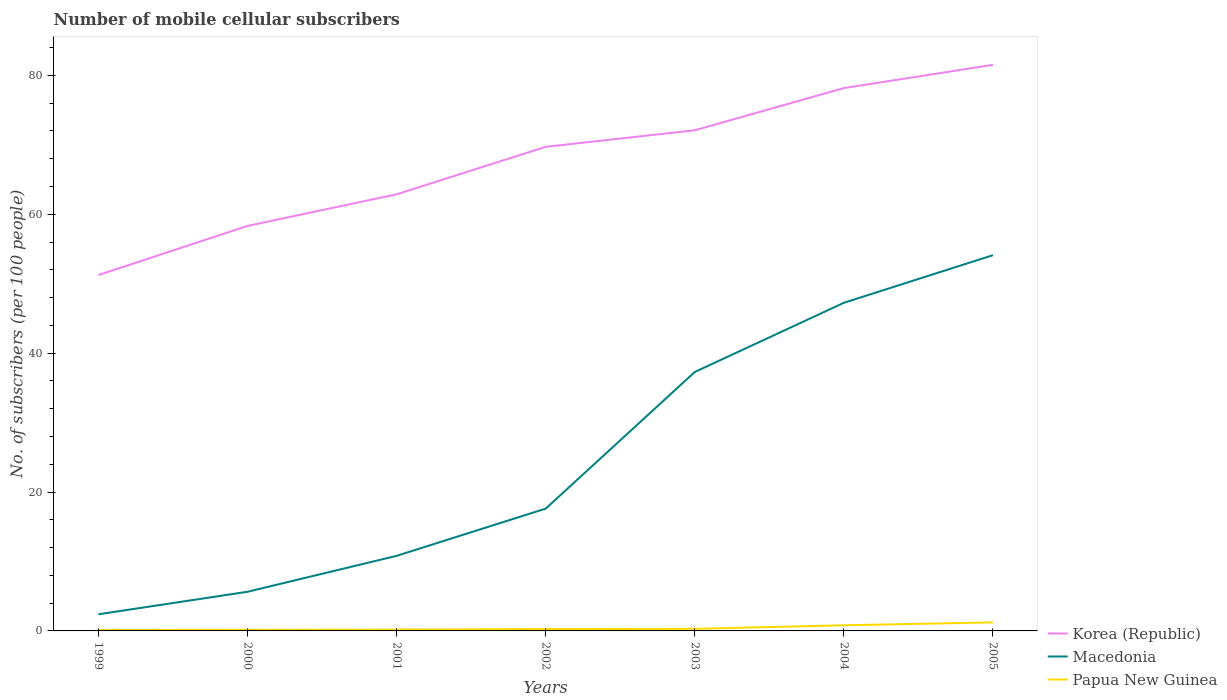How many different coloured lines are there?
Provide a short and direct response. 3. Is the number of lines equal to the number of legend labels?
Make the answer very short. Yes. Across all years, what is the maximum number of mobile cellular subscribers in Macedonia?
Your response must be concise. 2.4. What is the total number of mobile cellular subscribers in Papua New Guinea in the graph?
Offer a very short reply. -0.65. What is the difference between the highest and the second highest number of mobile cellular subscribers in Papua New Guinea?
Ensure brevity in your answer.  1.1. How many years are there in the graph?
Offer a terse response. 7. Does the graph contain any zero values?
Give a very brief answer. No. Does the graph contain grids?
Your answer should be compact. No. Where does the legend appear in the graph?
Give a very brief answer. Bottom right. What is the title of the graph?
Give a very brief answer. Number of mobile cellular subscribers. What is the label or title of the Y-axis?
Provide a succinct answer. No. of subscribers (per 100 people). What is the No. of subscribers (per 100 people) of Korea (Republic) in 1999?
Provide a succinct answer. 51.25. What is the No. of subscribers (per 100 people) in Macedonia in 1999?
Offer a terse response. 2.4. What is the No. of subscribers (per 100 people) in Papua New Guinea in 1999?
Give a very brief answer. 0.13. What is the No. of subscribers (per 100 people) of Korea (Republic) in 2000?
Give a very brief answer. 58.33. What is the No. of subscribers (per 100 people) in Macedonia in 2000?
Provide a succinct answer. 5.64. What is the No. of subscribers (per 100 people) of Papua New Guinea in 2000?
Provide a succinct answer. 0.16. What is the No. of subscribers (per 100 people) of Korea (Republic) in 2001?
Provide a succinct answer. 62.88. What is the No. of subscribers (per 100 people) in Macedonia in 2001?
Ensure brevity in your answer.  10.81. What is the No. of subscribers (per 100 people) of Papua New Guinea in 2001?
Your response must be concise. 0.19. What is the No. of subscribers (per 100 people) of Korea (Republic) in 2002?
Offer a terse response. 69.71. What is the No. of subscribers (per 100 people) of Macedonia in 2002?
Offer a terse response. 17.61. What is the No. of subscribers (per 100 people) in Papua New Guinea in 2002?
Offer a terse response. 0.27. What is the No. of subscribers (per 100 people) of Korea (Republic) in 2003?
Give a very brief answer. 72.1. What is the No. of subscribers (per 100 people) of Macedonia in 2003?
Make the answer very short. 37.29. What is the No. of subscribers (per 100 people) in Papua New Guinea in 2003?
Make the answer very short. 0.3. What is the No. of subscribers (per 100 people) of Korea (Republic) in 2004?
Make the answer very short. 78.17. What is the No. of subscribers (per 100 people) of Macedonia in 2004?
Give a very brief answer. 47.25. What is the No. of subscribers (per 100 people) of Papua New Guinea in 2004?
Your answer should be compact. 0.81. What is the No. of subscribers (per 100 people) in Korea (Republic) in 2005?
Make the answer very short. 81.52. What is the No. of subscribers (per 100 people) of Macedonia in 2005?
Give a very brief answer. 54.11. What is the No. of subscribers (per 100 people) in Papua New Guinea in 2005?
Keep it short and to the point. 1.23. Across all years, what is the maximum No. of subscribers (per 100 people) of Korea (Republic)?
Your answer should be compact. 81.52. Across all years, what is the maximum No. of subscribers (per 100 people) in Macedonia?
Provide a succinct answer. 54.11. Across all years, what is the maximum No. of subscribers (per 100 people) of Papua New Guinea?
Provide a succinct answer. 1.23. Across all years, what is the minimum No. of subscribers (per 100 people) of Korea (Republic)?
Provide a short and direct response. 51.25. Across all years, what is the minimum No. of subscribers (per 100 people) of Macedonia?
Provide a succinct answer. 2.4. Across all years, what is the minimum No. of subscribers (per 100 people) in Papua New Guinea?
Provide a short and direct response. 0.13. What is the total No. of subscribers (per 100 people) of Korea (Republic) in the graph?
Give a very brief answer. 473.96. What is the total No. of subscribers (per 100 people) in Macedonia in the graph?
Make the answer very short. 175.12. What is the total No. of subscribers (per 100 people) of Papua New Guinea in the graph?
Ensure brevity in your answer.  3.1. What is the difference between the No. of subscribers (per 100 people) of Korea (Republic) in 1999 and that in 2000?
Your response must be concise. -7.08. What is the difference between the No. of subscribers (per 100 people) of Macedonia in 1999 and that in 2000?
Your response must be concise. -3.25. What is the difference between the No. of subscribers (per 100 people) in Papua New Guinea in 1999 and that in 2000?
Your response must be concise. -0.02. What is the difference between the No. of subscribers (per 100 people) in Korea (Republic) in 1999 and that in 2001?
Keep it short and to the point. -11.63. What is the difference between the No. of subscribers (per 100 people) of Macedonia in 1999 and that in 2001?
Provide a succinct answer. -8.42. What is the difference between the No. of subscribers (per 100 people) of Papua New Guinea in 1999 and that in 2001?
Ensure brevity in your answer.  -0.06. What is the difference between the No. of subscribers (per 100 people) of Korea (Republic) in 1999 and that in 2002?
Keep it short and to the point. -18.46. What is the difference between the No. of subscribers (per 100 people) in Macedonia in 1999 and that in 2002?
Give a very brief answer. -15.22. What is the difference between the No. of subscribers (per 100 people) of Papua New Guinea in 1999 and that in 2002?
Provide a succinct answer. -0.13. What is the difference between the No. of subscribers (per 100 people) in Korea (Republic) in 1999 and that in 2003?
Offer a very short reply. -20.85. What is the difference between the No. of subscribers (per 100 people) in Macedonia in 1999 and that in 2003?
Provide a succinct answer. -34.9. What is the difference between the No. of subscribers (per 100 people) in Papua New Guinea in 1999 and that in 2003?
Provide a succinct answer. -0.17. What is the difference between the No. of subscribers (per 100 people) in Korea (Republic) in 1999 and that in 2004?
Your answer should be very brief. -26.92. What is the difference between the No. of subscribers (per 100 people) in Macedonia in 1999 and that in 2004?
Your response must be concise. -44.86. What is the difference between the No. of subscribers (per 100 people) in Papua New Guinea in 1999 and that in 2004?
Give a very brief answer. -0.68. What is the difference between the No. of subscribers (per 100 people) of Korea (Republic) in 1999 and that in 2005?
Give a very brief answer. -30.27. What is the difference between the No. of subscribers (per 100 people) in Macedonia in 1999 and that in 2005?
Ensure brevity in your answer.  -51.72. What is the difference between the No. of subscribers (per 100 people) of Papua New Guinea in 1999 and that in 2005?
Your response must be concise. -1.1. What is the difference between the No. of subscribers (per 100 people) in Korea (Republic) in 2000 and that in 2001?
Offer a terse response. -4.55. What is the difference between the No. of subscribers (per 100 people) in Macedonia in 2000 and that in 2001?
Provide a succinct answer. -5.17. What is the difference between the No. of subscribers (per 100 people) of Papua New Guinea in 2000 and that in 2001?
Your response must be concise. -0.03. What is the difference between the No. of subscribers (per 100 people) in Korea (Republic) in 2000 and that in 2002?
Provide a succinct answer. -11.39. What is the difference between the No. of subscribers (per 100 people) of Macedonia in 2000 and that in 2002?
Offer a terse response. -11.97. What is the difference between the No. of subscribers (per 100 people) in Papua New Guinea in 2000 and that in 2002?
Offer a very short reply. -0.11. What is the difference between the No. of subscribers (per 100 people) in Korea (Republic) in 2000 and that in 2003?
Make the answer very short. -13.77. What is the difference between the No. of subscribers (per 100 people) in Macedonia in 2000 and that in 2003?
Provide a succinct answer. -31.65. What is the difference between the No. of subscribers (per 100 people) of Papua New Guinea in 2000 and that in 2003?
Your answer should be very brief. -0.14. What is the difference between the No. of subscribers (per 100 people) in Korea (Republic) in 2000 and that in 2004?
Your answer should be compact. -19.85. What is the difference between the No. of subscribers (per 100 people) in Macedonia in 2000 and that in 2004?
Your answer should be compact. -41.61. What is the difference between the No. of subscribers (per 100 people) of Papua New Guinea in 2000 and that in 2004?
Provide a short and direct response. -0.65. What is the difference between the No. of subscribers (per 100 people) in Korea (Republic) in 2000 and that in 2005?
Your response must be concise. -23.2. What is the difference between the No. of subscribers (per 100 people) of Macedonia in 2000 and that in 2005?
Make the answer very short. -48.47. What is the difference between the No. of subscribers (per 100 people) of Papua New Guinea in 2000 and that in 2005?
Ensure brevity in your answer.  -1.07. What is the difference between the No. of subscribers (per 100 people) of Korea (Republic) in 2001 and that in 2002?
Ensure brevity in your answer.  -6.83. What is the difference between the No. of subscribers (per 100 people) of Macedonia in 2001 and that in 2002?
Your answer should be very brief. -6.8. What is the difference between the No. of subscribers (per 100 people) in Papua New Guinea in 2001 and that in 2002?
Provide a succinct answer. -0.07. What is the difference between the No. of subscribers (per 100 people) of Korea (Republic) in 2001 and that in 2003?
Offer a very short reply. -9.22. What is the difference between the No. of subscribers (per 100 people) of Macedonia in 2001 and that in 2003?
Offer a terse response. -26.48. What is the difference between the No. of subscribers (per 100 people) in Papua New Guinea in 2001 and that in 2003?
Give a very brief answer. -0.11. What is the difference between the No. of subscribers (per 100 people) in Korea (Republic) in 2001 and that in 2004?
Ensure brevity in your answer.  -15.29. What is the difference between the No. of subscribers (per 100 people) of Macedonia in 2001 and that in 2004?
Provide a succinct answer. -36.44. What is the difference between the No. of subscribers (per 100 people) of Papua New Guinea in 2001 and that in 2004?
Give a very brief answer. -0.62. What is the difference between the No. of subscribers (per 100 people) in Korea (Republic) in 2001 and that in 2005?
Offer a very short reply. -18.64. What is the difference between the No. of subscribers (per 100 people) in Macedonia in 2001 and that in 2005?
Ensure brevity in your answer.  -43.3. What is the difference between the No. of subscribers (per 100 people) in Papua New Guinea in 2001 and that in 2005?
Give a very brief answer. -1.04. What is the difference between the No. of subscribers (per 100 people) in Korea (Republic) in 2002 and that in 2003?
Your answer should be compact. -2.39. What is the difference between the No. of subscribers (per 100 people) of Macedonia in 2002 and that in 2003?
Your answer should be compact. -19.68. What is the difference between the No. of subscribers (per 100 people) in Papua New Guinea in 2002 and that in 2003?
Offer a very short reply. -0.04. What is the difference between the No. of subscribers (per 100 people) of Korea (Republic) in 2002 and that in 2004?
Your response must be concise. -8.46. What is the difference between the No. of subscribers (per 100 people) of Macedonia in 2002 and that in 2004?
Your answer should be very brief. -29.64. What is the difference between the No. of subscribers (per 100 people) of Papua New Guinea in 2002 and that in 2004?
Give a very brief answer. -0.55. What is the difference between the No. of subscribers (per 100 people) in Korea (Republic) in 2002 and that in 2005?
Provide a succinct answer. -11.81. What is the difference between the No. of subscribers (per 100 people) of Macedonia in 2002 and that in 2005?
Your response must be concise. -36.5. What is the difference between the No. of subscribers (per 100 people) of Papua New Guinea in 2002 and that in 2005?
Give a very brief answer. -0.97. What is the difference between the No. of subscribers (per 100 people) of Korea (Republic) in 2003 and that in 2004?
Provide a short and direct response. -6.08. What is the difference between the No. of subscribers (per 100 people) of Macedonia in 2003 and that in 2004?
Offer a terse response. -9.96. What is the difference between the No. of subscribers (per 100 people) of Papua New Guinea in 2003 and that in 2004?
Provide a succinct answer. -0.51. What is the difference between the No. of subscribers (per 100 people) in Korea (Republic) in 2003 and that in 2005?
Ensure brevity in your answer.  -9.42. What is the difference between the No. of subscribers (per 100 people) in Macedonia in 2003 and that in 2005?
Make the answer very short. -16.82. What is the difference between the No. of subscribers (per 100 people) in Papua New Guinea in 2003 and that in 2005?
Keep it short and to the point. -0.93. What is the difference between the No. of subscribers (per 100 people) of Korea (Republic) in 2004 and that in 2005?
Ensure brevity in your answer.  -3.35. What is the difference between the No. of subscribers (per 100 people) in Macedonia in 2004 and that in 2005?
Your response must be concise. -6.86. What is the difference between the No. of subscribers (per 100 people) of Papua New Guinea in 2004 and that in 2005?
Your response must be concise. -0.42. What is the difference between the No. of subscribers (per 100 people) of Korea (Republic) in 1999 and the No. of subscribers (per 100 people) of Macedonia in 2000?
Keep it short and to the point. 45.61. What is the difference between the No. of subscribers (per 100 people) in Korea (Republic) in 1999 and the No. of subscribers (per 100 people) in Papua New Guinea in 2000?
Keep it short and to the point. 51.09. What is the difference between the No. of subscribers (per 100 people) of Macedonia in 1999 and the No. of subscribers (per 100 people) of Papua New Guinea in 2000?
Provide a short and direct response. 2.24. What is the difference between the No. of subscribers (per 100 people) of Korea (Republic) in 1999 and the No. of subscribers (per 100 people) of Macedonia in 2001?
Offer a terse response. 40.44. What is the difference between the No. of subscribers (per 100 people) in Korea (Republic) in 1999 and the No. of subscribers (per 100 people) in Papua New Guinea in 2001?
Make the answer very short. 51.06. What is the difference between the No. of subscribers (per 100 people) of Macedonia in 1999 and the No. of subscribers (per 100 people) of Papua New Guinea in 2001?
Your answer should be compact. 2.2. What is the difference between the No. of subscribers (per 100 people) in Korea (Republic) in 1999 and the No. of subscribers (per 100 people) in Macedonia in 2002?
Offer a very short reply. 33.64. What is the difference between the No. of subscribers (per 100 people) in Korea (Republic) in 1999 and the No. of subscribers (per 100 people) in Papua New Guinea in 2002?
Your answer should be very brief. 50.98. What is the difference between the No. of subscribers (per 100 people) in Macedonia in 1999 and the No. of subscribers (per 100 people) in Papua New Guinea in 2002?
Your answer should be very brief. 2.13. What is the difference between the No. of subscribers (per 100 people) of Korea (Republic) in 1999 and the No. of subscribers (per 100 people) of Macedonia in 2003?
Your response must be concise. 13.96. What is the difference between the No. of subscribers (per 100 people) in Korea (Republic) in 1999 and the No. of subscribers (per 100 people) in Papua New Guinea in 2003?
Provide a short and direct response. 50.95. What is the difference between the No. of subscribers (per 100 people) in Macedonia in 1999 and the No. of subscribers (per 100 people) in Papua New Guinea in 2003?
Your answer should be very brief. 2.09. What is the difference between the No. of subscribers (per 100 people) in Korea (Republic) in 1999 and the No. of subscribers (per 100 people) in Macedonia in 2004?
Keep it short and to the point. 4. What is the difference between the No. of subscribers (per 100 people) in Korea (Republic) in 1999 and the No. of subscribers (per 100 people) in Papua New Guinea in 2004?
Your answer should be very brief. 50.44. What is the difference between the No. of subscribers (per 100 people) in Macedonia in 1999 and the No. of subscribers (per 100 people) in Papua New Guinea in 2004?
Provide a short and direct response. 1.58. What is the difference between the No. of subscribers (per 100 people) in Korea (Republic) in 1999 and the No. of subscribers (per 100 people) in Macedonia in 2005?
Provide a succinct answer. -2.86. What is the difference between the No. of subscribers (per 100 people) of Korea (Republic) in 1999 and the No. of subscribers (per 100 people) of Papua New Guinea in 2005?
Give a very brief answer. 50.02. What is the difference between the No. of subscribers (per 100 people) of Macedonia in 1999 and the No. of subscribers (per 100 people) of Papua New Guinea in 2005?
Your answer should be compact. 1.17. What is the difference between the No. of subscribers (per 100 people) in Korea (Republic) in 2000 and the No. of subscribers (per 100 people) in Macedonia in 2001?
Provide a short and direct response. 47.51. What is the difference between the No. of subscribers (per 100 people) of Korea (Republic) in 2000 and the No. of subscribers (per 100 people) of Papua New Guinea in 2001?
Make the answer very short. 58.13. What is the difference between the No. of subscribers (per 100 people) of Macedonia in 2000 and the No. of subscribers (per 100 people) of Papua New Guinea in 2001?
Keep it short and to the point. 5.45. What is the difference between the No. of subscribers (per 100 people) in Korea (Republic) in 2000 and the No. of subscribers (per 100 people) in Macedonia in 2002?
Make the answer very short. 40.71. What is the difference between the No. of subscribers (per 100 people) of Korea (Republic) in 2000 and the No. of subscribers (per 100 people) of Papua New Guinea in 2002?
Your answer should be very brief. 58.06. What is the difference between the No. of subscribers (per 100 people) in Macedonia in 2000 and the No. of subscribers (per 100 people) in Papua New Guinea in 2002?
Keep it short and to the point. 5.38. What is the difference between the No. of subscribers (per 100 people) in Korea (Republic) in 2000 and the No. of subscribers (per 100 people) in Macedonia in 2003?
Your response must be concise. 21.03. What is the difference between the No. of subscribers (per 100 people) of Korea (Republic) in 2000 and the No. of subscribers (per 100 people) of Papua New Guinea in 2003?
Your answer should be compact. 58.02. What is the difference between the No. of subscribers (per 100 people) in Macedonia in 2000 and the No. of subscribers (per 100 people) in Papua New Guinea in 2003?
Provide a short and direct response. 5.34. What is the difference between the No. of subscribers (per 100 people) of Korea (Republic) in 2000 and the No. of subscribers (per 100 people) of Macedonia in 2004?
Your answer should be compact. 11.07. What is the difference between the No. of subscribers (per 100 people) of Korea (Republic) in 2000 and the No. of subscribers (per 100 people) of Papua New Guinea in 2004?
Make the answer very short. 57.51. What is the difference between the No. of subscribers (per 100 people) in Macedonia in 2000 and the No. of subscribers (per 100 people) in Papua New Guinea in 2004?
Offer a terse response. 4.83. What is the difference between the No. of subscribers (per 100 people) of Korea (Republic) in 2000 and the No. of subscribers (per 100 people) of Macedonia in 2005?
Make the answer very short. 4.21. What is the difference between the No. of subscribers (per 100 people) in Korea (Republic) in 2000 and the No. of subscribers (per 100 people) in Papua New Guinea in 2005?
Give a very brief answer. 57.1. What is the difference between the No. of subscribers (per 100 people) in Macedonia in 2000 and the No. of subscribers (per 100 people) in Papua New Guinea in 2005?
Your response must be concise. 4.41. What is the difference between the No. of subscribers (per 100 people) in Korea (Republic) in 2001 and the No. of subscribers (per 100 people) in Macedonia in 2002?
Ensure brevity in your answer.  45.27. What is the difference between the No. of subscribers (per 100 people) in Korea (Republic) in 2001 and the No. of subscribers (per 100 people) in Papua New Guinea in 2002?
Give a very brief answer. 62.61. What is the difference between the No. of subscribers (per 100 people) of Macedonia in 2001 and the No. of subscribers (per 100 people) of Papua New Guinea in 2002?
Your answer should be compact. 10.55. What is the difference between the No. of subscribers (per 100 people) in Korea (Republic) in 2001 and the No. of subscribers (per 100 people) in Macedonia in 2003?
Your answer should be compact. 25.59. What is the difference between the No. of subscribers (per 100 people) in Korea (Republic) in 2001 and the No. of subscribers (per 100 people) in Papua New Guinea in 2003?
Ensure brevity in your answer.  62.58. What is the difference between the No. of subscribers (per 100 people) of Macedonia in 2001 and the No. of subscribers (per 100 people) of Papua New Guinea in 2003?
Offer a terse response. 10.51. What is the difference between the No. of subscribers (per 100 people) in Korea (Republic) in 2001 and the No. of subscribers (per 100 people) in Macedonia in 2004?
Give a very brief answer. 15.62. What is the difference between the No. of subscribers (per 100 people) in Korea (Republic) in 2001 and the No. of subscribers (per 100 people) in Papua New Guinea in 2004?
Give a very brief answer. 62.07. What is the difference between the No. of subscribers (per 100 people) in Macedonia in 2001 and the No. of subscribers (per 100 people) in Papua New Guinea in 2004?
Your answer should be compact. 10. What is the difference between the No. of subscribers (per 100 people) in Korea (Republic) in 2001 and the No. of subscribers (per 100 people) in Macedonia in 2005?
Ensure brevity in your answer.  8.76. What is the difference between the No. of subscribers (per 100 people) of Korea (Republic) in 2001 and the No. of subscribers (per 100 people) of Papua New Guinea in 2005?
Make the answer very short. 61.65. What is the difference between the No. of subscribers (per 100 people) in Macedonia in 2001 and the No. of subscribers (per 100 people) in Papua New Guinea in 2005?
Give a very brief answer. 9.58. What is the difference between the No. of subscribers (per 100 people) of Korea (Republic) in 2002 and the No. of subscribers (per 100 people) of Macedonia in 2003?
Your answer should be compact. 32.42. What is the difference between the No. of subscribers (per 100 people) of Korea (Republic) in 2002 and the No. of subscribers (per 100 people) of Papua New Guinea in 2003?
Provide a short and direct response. 69.41. What is the difference between the No. of subscribers (per 100 people) in Macedonia in 2002 and the No. of subscribers (per 100 people) in Papua New Guinea in 2003?
Keep it short and to the point. 17.31. What is the difference between the No. of subscribers (per 100 people) in Korea (Republic) in 2002 and the No. of subscribers (per 100 people) in Macedonia in 2004?
Your response must be concise. 22.46. What is the difference between the No. of subscribers (per 100 people) of Korea (Republic) in 2002 and the No. of subscribers (per 100 people) of Papua New Guinea in 2004?
Give a very brief answer. 68.9. What is the difference between the No. of subscribers (per 100 people) in Macedonia in 2002 and the No. of subscribers (per 100 people) in Papua New Guinea in 2004?
Your answer should be compact. 16.8. What is the difference between the No. of subscribers (per 100 people) in Korea (Republic) in 2002 and the No. of subscribers (per 100 people) in Macedonia in 2005?
Offer a very short reply. 15.6. What is the difference between the No. of subscribers (per 100 people) of Korea (Republic) in 2002 and the No. of subscribers (per 100 people) of Papua New Guinea in 2005?
Offer a terse response. 68.48. What is the difference between the No. of subscribers (per 100 people) in Macedonia in 2002 and the No. of subscribers (per 100 people) in Papua New Guinea in 2005?
Your answer should be very brief. 16.38. What is the difference between the No. of subscribers (per 100 people) of Korea (Republic) in 2003 and the No. of subscribers (per 100 people) of Macedonia in 2004?
Your answer should be compact. 24.84. What is the difference between the No. of subscribers (per 100 people) in Korea (Republic) in 2003 and the No. of subscribers (per 100 people) in Papua New Guinea in 2004?
Give a very brief answer. 71.29. What is the difference between the No. of subscribers (per 100 people) in Macedonia in 2003 and the No. of subscribers (per 100 people) in Papua New Guinea in 2004?
Make the answer very short. 36.48. What is the difference between the No. of subscribers (per 100 people) of Korea (Republic) in 2003 and the No. of subscribers (per 100 people) of Macedonia in 2005?
Provide a short and direct response. 17.98. What is the difference between the No. of subscribers (per 100 people) of Korea (Republic) in 2003 and the No. of subscribers (per 100 people) of Papua New Guinea in 2005?
Make the answer very short. 70.87. What is the difference between the No. of subscribers (per 100 people) of Macedonia in 2003 and the No. of subscribers (per 100 people) of Papua New Guinea in 2005?
Provide a succinct answer. 36.06. What is the difference between the No. of subscribers (per 100 people) of Korea (Republic) in 2004 and the No. of subscribers (per 100 people) of Macedonia in 2005?
Give a very brief answer. 24.06. What is the difference between the No. of subscribers (per 100 people) in Korea (Republic) in 2004 and the No. of subscribers (per 100 people) in Papua New Guinea in 2005?
Your answer should be very brief. 76.94. What is the difference between the No. of subscribers (per 100 people) of Macedonia in 2004 and the No. of subscribers (per 100 people) of Papua New Guinea in 2005?
Keep it short and to the point. 46.02. What is the average No. of subscribers (per 100 people) in Korea (Republic) per year?
Provide a succinct answer. 67.71. What is the average No. of subscribers (per 100 people) of Macedonia per year?
Keep it short and to the point. 25.02. What is the average No. of subscribers (per 100 people) of Papua New Guinea per year?
Give a very brief answer. 0.44. In the year 1999, what is the difference between the No. of subscribers (per 100 people) in Korea (Republic) and No. of subscribers (per 100 people) in Macedonia?
Your response must be concise. 48.85. In the year 1999, what is the difference between the No. of subscribers (per 100 people) in Korea (Republic) and No. of subscribers (per 100 people) in Papua New Guinea?
Provide a succinct answer. 51.12. In the year 1999, what is the difference between the No. of subscribers (per 100 people) in Macedonia and No. of subscribers (per 100 people) in Papua New Guinea?
Ensure brevity in your answer.  2.26. In the year 2000, what is the difference between the No. of subscribers (per 100 people) of Korea (Republic) and No. of subscribers (per 100 people) of Macedonia?
Your answer should be compact. 52.69. In the year 2000, what is the difference between the No. of subscribers (per 100 people) in Korea (Republic) and No. of subscribers (per 100 people) in Papua New Guinea?
Your response must be concise. 58.17. In the year 2000, what is the difference between the No. of subscribers (per 100 people) in Macedonia and No. of subscribers (per 100 people) in Papua New Guinea?
Ensure brevity in your answer.  5.48. In the year 2001, what is the difference between the No. of subscribers (per 100 people) of Korea (Republic) and No. of subscribers (per 100 people) of Macedonia?
Your answer should be very brief. 52.07. In the year 2001, what is the difference between the No. of subscribers (per 100 people) of Korea (Republic) and No. of subscribers (per 100 people) of Papua New Guinea?
Ensure brevity in your answer.  62.69. In the year 2001, what is the difference between the No. of subscribers (per 100 people) in Macedonia and No. of subscribers (per 100 people) in Papua New Guinea?
Ensure brevity in your answer.  10.62. In the year 2002, what is the difference between the No. of subscribers (per 100 people) in Korea (Republic) and No. of subscribers (per 100 people) in Macedonia?
Give a very brief answer. 52.1. In the year 2002, what is the difference between the No. of subscribers (per 100 people) of Korea (Republic) and No. of subscribers (per 100 people) of Papua New Guinea?
Keep it short and to the point. 69.45. In the year 2002, what is the difference between the No. of subscribers (per 100 people) of Macedonia and No. of subscribers (per 100 people) of Papua New Guinea?
Your response must be concise. 17.35. In the year 2003, what is the difference between the No. of subscribers (per 100 people) in Korea (Republic) and No. of subscribers (per 100 people) in Macedonia?
Your answer should be very brief. 34.81. In the year 2003, what is the difference between the No. of subscribers (per 100 people) of Korea (Republic) and No. of subscribers (per 100 people) of Papua New Guinea?
Provide a short and direct response. 71.8. In the year 2003, what is the difference between the No. of subscribers (per 100 people) of Macedonia and No. of subscribers (per 100 people) of Papua New Guinea?
Your response must be concise. 36.99. In the year 2004, what is the difference between the No. of subscribers (per 100 people) of Korea (Republic) and No. of subscribers (per 100 people) of Macedonia?
Offer a terse response. 30.92. In the year 2004, what is the difference between the No. of subscribers (per 100 people) of Korea (Republic) and No. of subscribers (per 100 people) of Papua New Guinea?
Make the answer very short. 77.36. In the year 2004, what is the difference between the No. of subscribers (per 100 people) in Macedonia and No. of subscribers (per 100 people) in Papua New Guinea?
Keep it short and to the point. 46.44. In the year 2005, what is the difference between the No. of subscribers (per 100 people) in Korea (Republic) and No. of subscribers (per 100 people) in Macedonia?
Keep it short and to the point. 27.41. In the year 2005, what is the difference between the No. of subscribers (per 100 people) in Korea (Republic) and No. of subscribers (per 100 people) in Papua New Guinea?
Ensure brevity in your answer.  80.29. In the year 2005, what is the difference between the No. of subscribers (per 100 people) in Macedonia and No. of subscribers (per 100 people) in Papua New Guinea?
Your response must be concise. 52.88. What is the ratio of the No. of subscribers (per 100 people) in Korea (Republic) in 1999 to that in 2000?
Give a very brief answer. 0.88. What is the ratio of the No. of subscribers (per 100 people) in Macedonia in 1999 to that in 2000?
Ensure brevity in your answer.  0.42. What is the ratio of the No. of subscribers (per 100 people) in Papua New Guinea in 1999 to that in 2000?
Keep it short and to the point. 0.85. What is the ratio of the No. of subscribers (per 100 people) of Korea (Republic) in 1999 to that in 2001?
Your answer should be very brief. 0.82. What is the ratio of the No. of subscribers (per 100 people) of Macedonia in 1999 to that in 2001?
Your answer should be compact. 0.22. What is the ratio of the No. of subscribers (per 100 people) of Papua New Guinea in 1999 to that in 2001?
Ensure brevity in your answer.  0.69. What is the ratio of the No. of subscribers (per 100 people) of Korea (Republic) in 1999 to that in 2002?
Offer a very short reply. 0.74. What is the ratio of the No. of subscribers (per 100 people) in Macedonia in 1999 to that in 2002?
Give a very brief answer. 0.14. What is the ratio of the No. of subscribers (per 100 people) in Papua New Guinea in 1999 to that in 2002?
Make the answer very short. 0.51. What is the ratio of the No. of subscribers (per 100 people) in Korea (Republic) in 1999 to that in 2003?
Provide a short and direct response. 0.71. What is the ratio of the No. of subscribers (per 100 people) of Macedonia in 1999 to that in 2003?
Keep it short and to the point. 0.06. What is the ratio of the No. of subscribers (per 100 people) in Papua New Guinea in 1999 to that in 2003?
Provide a short and direct response. 0.45. What is the ratio of the No. of subscribers (per 100 people) in Korea (Republic) in 1999 to that in 2004?
Provide a short and direct response. 0.66. What is the ratio of the No. of subscribers (per 100 people) of Macedonia in 1999 to that in 2004?
Your response must be concise. 0.05. What is the ratio of the No. of subscribers (per 100 people) in Papua New Guinea in 1999 to that in 2004?
Ensure brevity in your answer.  0.17. What is the ratio of the No. of subscribers (per 100 people) of Korea (Republic) in 1999 to that in 2005?
Offer a very short reply. 0.63. What is the ratio of the No. of subscribers (per 100 people) of Macedonia in 1999 to that in 2005?
Your response must be concise. 0.04. What is the ratio of the No. of subscribers (per 100 people) in Papua New Guinea in 1999 to that in 2005?
Provide a short and direct response. 0.11. What is the ratio of the No. of subscribers (per 100 people) in Korea (Republic) in 2000 to that in 2001?
Provide a succinct answer. 0.93. What is the ratio of the No. of subscribers (per 100 people) in Macedonia in 2000 to that in 2001?
Offer a very short reply. 0.52. What is the ratio of the No. of subscribers (per 100 people) of Papua New Guinea in 2000 to that in 2001?
Give a very brief answer. 0.82. What is the ratio of the No. of subscribers (per 100 people) of Korea (Republic) in 2000 to that in 2002?
Give a very brief answer. 0.84. What is the ratio of the No. of subscribers (per 100 people) of Macedonia in 2000 to that in 2002?
Provide a short and direct response. 0.32. What is the ratio of the No. of subscribers (per 100 people) in Papua New Guinea in 2000 to that in 2002?
Provide a succinct answer. 0.6. What is the ratio of the No. of subscribers (per 100 people) of Korea (Republic) in 2000 to that in 2003?
Make the answer very short. 0.81. What is the ratio of the No. of subscribers (per 100 people) in Macedonia in 2000 to that in 2003?
Provide a short and direct response. 0.15. What is the ratio of the No. of subscribers (per 100 people) of Papua New Guinea in 2000 to that in 2003?
Offer a very short reply. 0.53. What is the ratio of the No. of subscribers (per 100 people) in Korea (Republic) in 2000 to that in 2004?
Your answer should be very brief. 0.75. What is the ratio of the No. of subscribers (per 100 people) of Macedonia in 2000 to that in 2004?
Provide a succinct answer. 0.12. What is the ratio of the No. of subscribers (per 100 people) in Papua New Guinea in 2000 to that in 2004?
Give a very brief answer. 0.2. What is the ratio of the No. of subscribers (per 100 people) in Korea (Republic) in 2000 to that in 2005?
Provide a short and direct response. 0.72. What is the ratio of the No. of subscribers (per 100 people) in Macedonia in 2000 to that in 2005?
Give a very brief answer. 0.1. What is the ratio of the No. of subscribers (per 100 people) in Papua New Guinea in 2000 to that in 2005?
Offer a terse response. 0.13. What is the ratio of the No. of subscribers (per 100 people) in Korea (Republic) in 2001 to that in 2002?
Offer a terse response. 0.9. What is the ratio of the No. of subscribers (per 100 people) in Macedonia in 2001 to that in 2002?
Give a very brief answer. 0.61. What is the ratio of the No. of subscribers (per 100 people) of Papua New Guinea in 2001 to that in 2002?
Make the answer very short. 0.73. What is the ratio of the No. of subscribers (per 100 people) of Korea (Republic) in 2001 to that in 2003?
Your answer should be very brief. 0.87. What is the ratio of the No. of subscribers (per 100 people) in Macedonia in 2001 to that in 2003?
Keep it short and to the point. 0.29. What is the ratio of the No. of subscribers (per 100 people) in Papua New Guinea in 2001 to that in 2003?
Your answer should be compact. 0.64. What is the ratio of the No. of subscribers (per 100 people) in Korea (Republic) in 2001 to that in 2004?
Your answer should be very brief. 0.8. What is the ratio of the No. of subscribers (per 100 people) of Macedonia in 2001 to that in 2004?
Offer a very short reply. 0.23. What is the ratio of the No. of subscribers (per 100 people) of Papua New Guinea in 2001 to that in 2004?
Your answer should be compact. 0.24. What is the ratio of the No. of subscribers (per 100 people) of Korea (Republic) in 2001 to that in 2005?
Make the answer very short. 0.77. What is the ratio of the No. of subscribers (per 100 people) in Macedonia in 2001 to that in 2005?
Give a very brief answer. 0.2. What is the ratio of the No. of subscribers (per 100 people) in Papua New Guinea in 2001 to that in 2005?
Give a very brief answer. 0.16. What is the ratio of the No. of subscribers (per 100 people) of Korea (Republic) in 2002 to that in 2003?
Provide a succinct answer. 0.97. What is the ratio of the No. of subscribers (per 100 people) of Macedonia in 2002 to that in 2003?
Offer a very short reply. 0.47. What is the ratio of the No. of subscribers (per 100 people) in Papua New Guinea in 2002 to that in 2003?
Offer a very short reply. 0.88. What is the ratio of the No. of subscribers (per 100 people) of Korea (Republic) in 2002 to that in 2004?
Your response must be concise. 0.89. What is the ratio of the No. of subscribers (per 100 people) of Macedonia in 2002 to that in 2004?
Make the answer very short. 0.37. What is the ratio of the No. of subscribers (per 100 people) in Papua New Guinea in 2002 to that in 2004?
Your answer should be compact. 0.33. What is the ratio of the No. of subscribers (per 100 people) in Korea (Republic) in 2002 to that in 2005?
Your answer should be very brief. 0.86. What is the ratio of the No. of subscribers (per 100 people) in Macedonia in 2002 to that in 2005?
Give a very brief answer. 0.33. What is the ratio of the No. of subscribers (per 100 people) in Papua New Guinea in 2002 to that in 2005?
Offer a terse response. 0.22. What is the ratio of the No. of subscribers (per 100 people) in Korea (Republic) in 2003 to that in 2004?
Your response must be concise. 0.92. What is the ratio of the No. of subscribers (per 100 people) of Macedonia in 2003 to that in 2004?
Offer a terse response. 0.79. What is the ratio of the No. of subscribers (per 100 people) of Papua New Guinea in 2003 to that in 2004?
Your response must be concise. 0.37. What is the ratio of the No. of subscribers (per 100 people) in Korea (Republic) in 2003 to that in 2005?
Your answer should be very brief. 0.88. What is the ratio of the No. of subscribers (per 100 people) of Macedonia in 2003 to that in 2005?
Ensure brevity in your answer.  0.69. What is the ratio of the No. of subscribers (per 100 people) in Papua New Guinea in 2003 to that in 2005?
Your answer should be very brief. 0.25. What is the ratio of the No. of subscribers (per 100 people) of Korea (Republic) in 2004 to that in 2005?
Your response must be concise. 0.96. What is the ratio of the No. of subscribers (per 100 people) in Macedonia in 2004 to that in 2005?
Your answer should be compact. 0.87. What is the ratio of the No. of subscribers (per 100 people) of Papua New Guinea in 2004 to that in 2005?
Ensure brevity in your answer.  0.66. What is the difference between the highest and the second highest No. of subscribers (per 100 people) in Korea (Republic)?
Your response must be concise. 3.35. What is the difference between the highest and the second highest No. of subscribers (per 100 people) in Macedonia?
Give a very brief answer. 6.86. What is the difference between the highest and the second highest No. of subscribers (per 100 people) in Papua New Guinea?
Provide a succinct answer. 0.42. What is the difference between the highest and the lowest No. of subscribers (per 100 people) in Korea (Republic)?
Ensure brevity in your answer.  30.27. What is the difference between the highest and the lowest No. of subscribers (per 100 people) of Macedonia?
Ensure brevity in your answer.  51.72. What is the difference between the highest and the lowest No. of subscribers (per 100 people) of Papua New Guinea?
Your answer should be very brief. 1.1. 